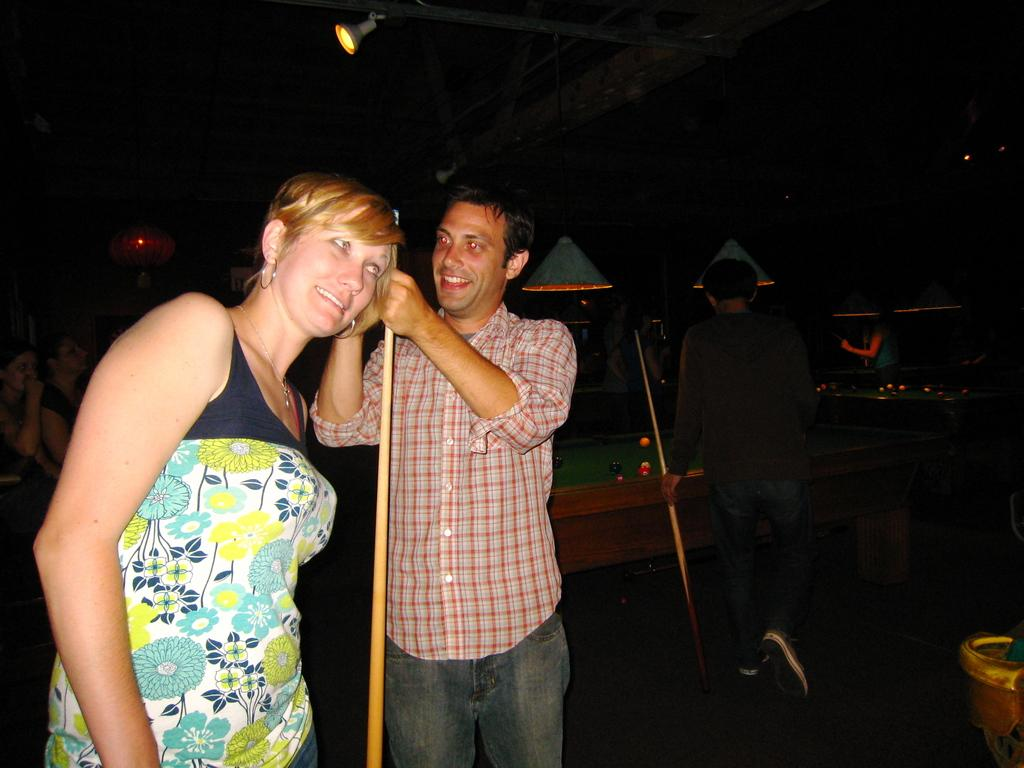What is the person in the image wearing? The person is wearing a red shirt in the image. What is the person holding in the image? The person is holding a snooker stick in the image. Who is standing beside the person with the red shirt? There is another woman standing beside the person with the red shirt. What can be seen on the table in the image? There is a snooker table in the image. Can you describe the setting of the image? There is a person in the background of the image. What type of butter is being used on the snooker table in the image? There is no butter present in the image; it features a snooker table and people holding snooker sticks. What kind of pets can be seen playing with the snooker balls in the image? There are no pets present in the image; it only features people and a snooker table. 